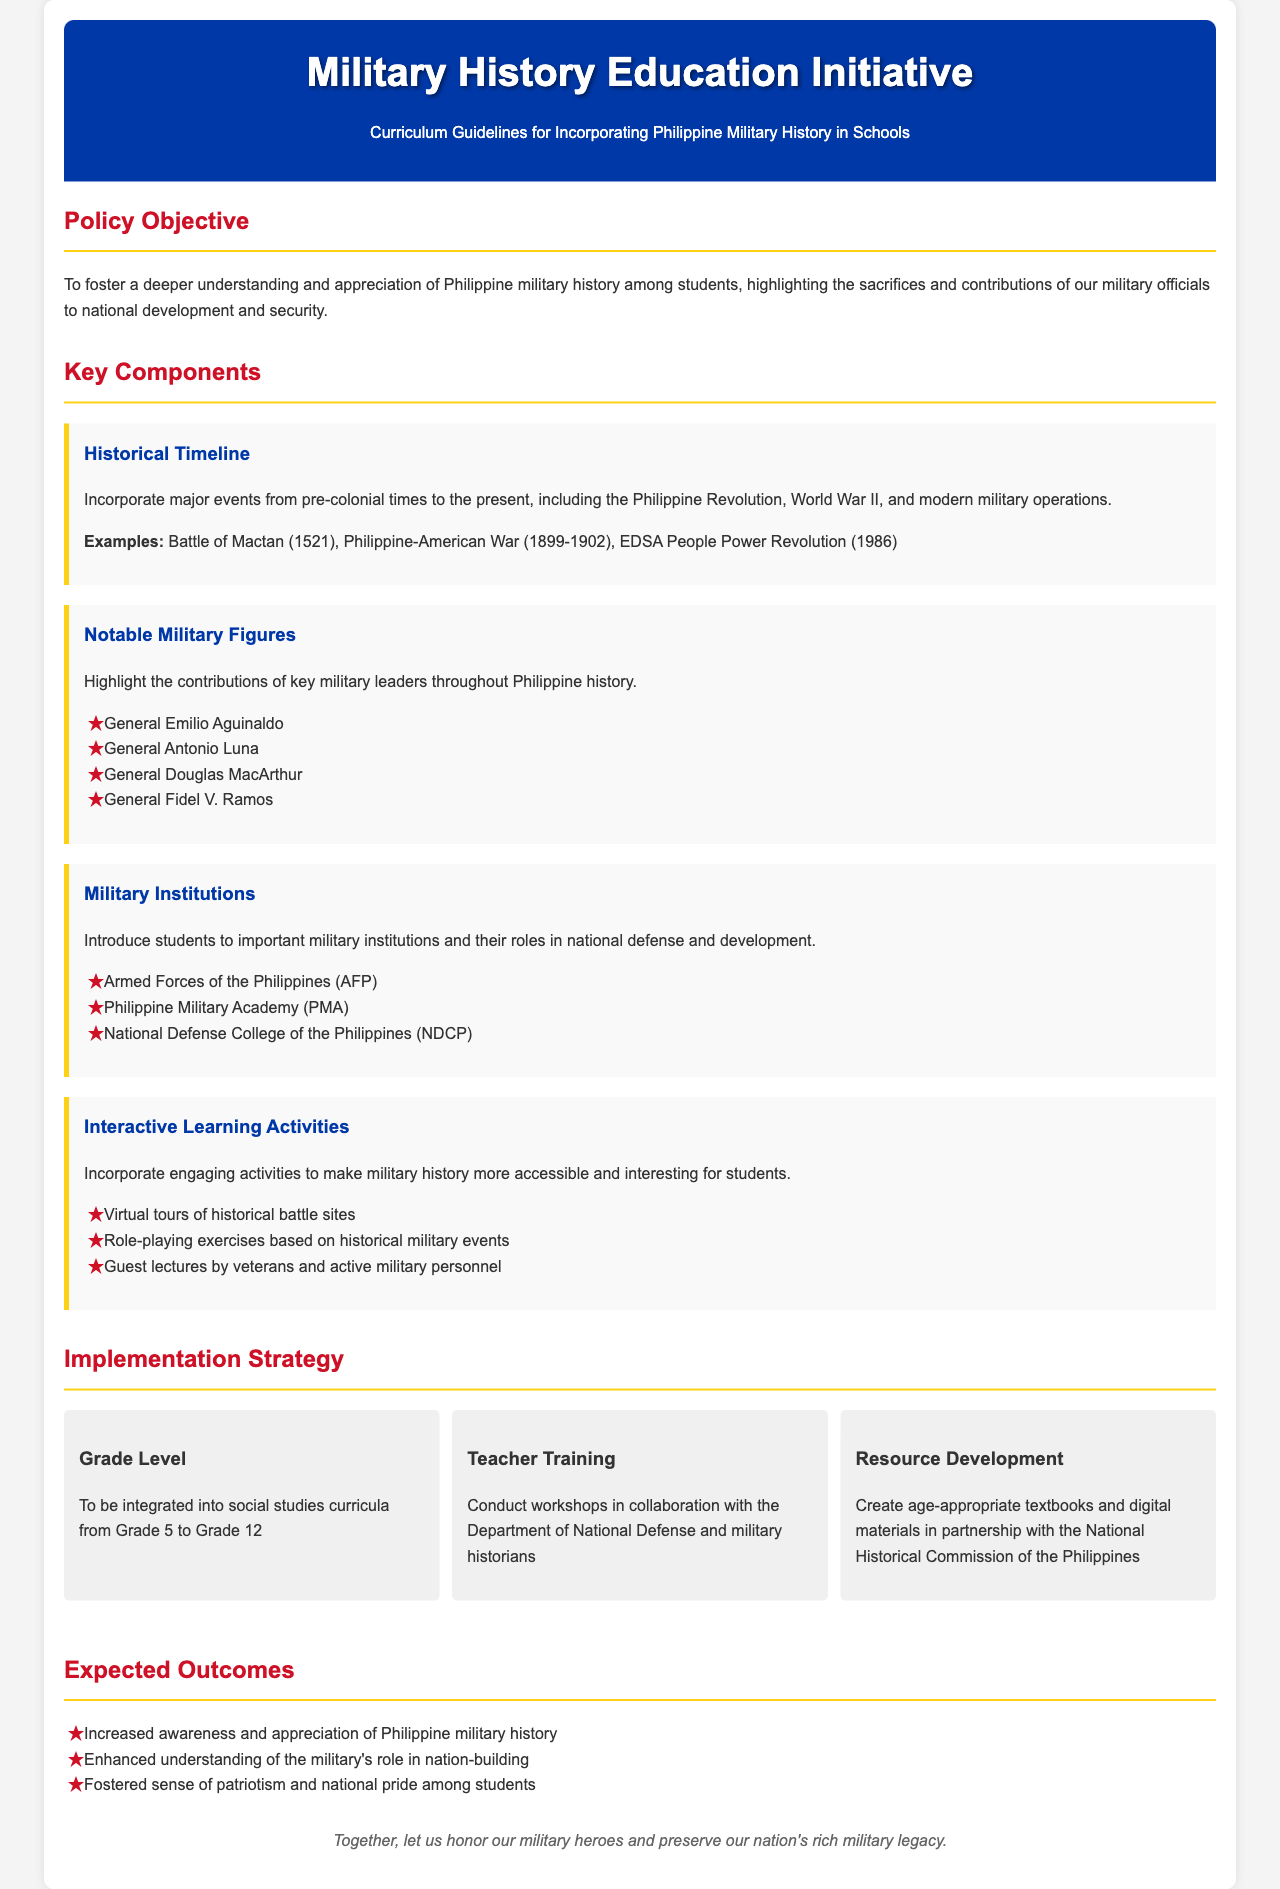What is the main goal of the policy? The main goal is to foster a deeper understanding and appreciation of Philippine military history among students.
Answer: To foster a deeper understanding and appreciation of Philippine military history among students What is one example of a historical event included in the guidelines? The document mentions several major events; one example is the Battle of Mactan.
Answer: Battle of Mactan Who is one notable military figure highlighted in the document? The document lists several figures; one included is General Emilio Aguinaldo.
Answer: General Emilio Aguinaldo What grade levels will the curriculum be integrated into? The document specifies that it will be integrated from Grade 5 to Grade 12.
Answer: Grade 5 to Grade 12 What type of learning activity is suggested in the guidelines? One of the engaging activities suggested is virtual tours of historical battle sites.
Answer: Virtual tours of historical battle sites What is one expected outcome of this initiative? The document states that one expected outcome is increased awareness and appreciation of Philippine military history.
Answer: Increased awareness and appreciation of Philippine military history Which organizations are involved in teacher training? The document mentions collaboration with the Department of National Defense and military historians for teacher training.
Answer: Department of National Defense and military historians What is the purpose of resource development in the initiative? The purpose is to create age-appropriate textbooks and digital materials.
Answer: Create age-appropriate textbooks and digital materials 